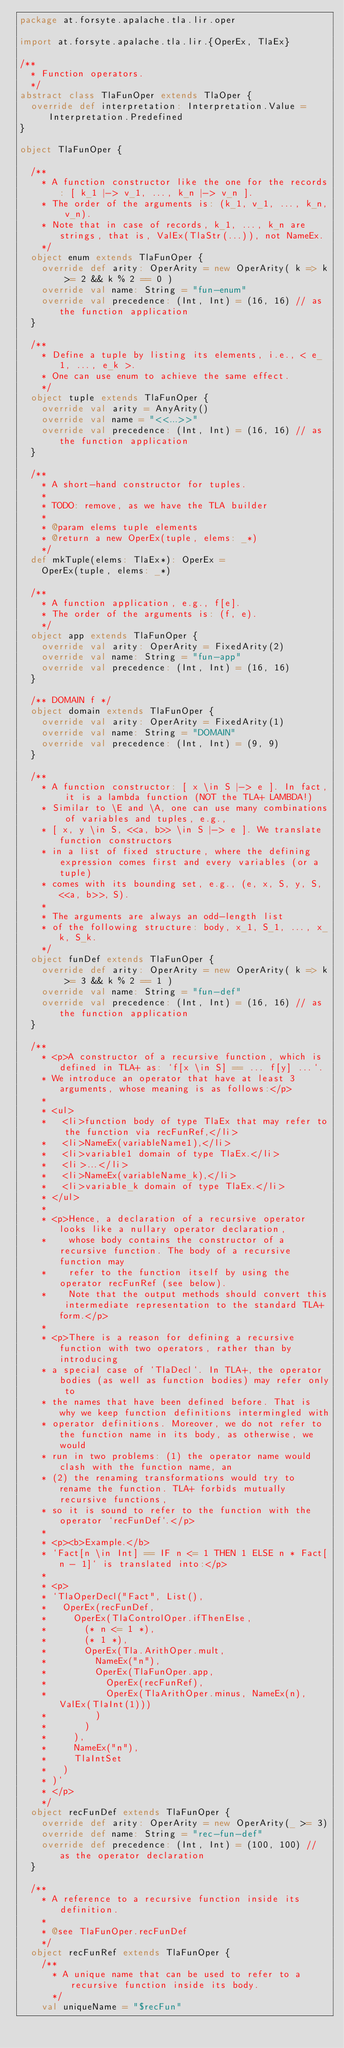Convert code to text. <code><loc_0><loc_0><loc_500><loc_500><_Scala_>package at.forsyte.apalache.tla.lir.oper

import at.forsyte.apalache.tla.lir.{OperEx, TlaEx}

/**
  * Function operators.
  */
abstract class TlaFunOper extends TlaOper {
  override def interpretation: Interpretation.Value = Interpretation.Predefined
}

object TlaFunOper {

  /**
    * A function constructor like the one for the records: [ k_1 |-> v_1, ..., k_n |-> v_n ].
    * The order of the arguments is: (k_1, v_1, ..., k_n, v_n).
    * Note that in case of records, k_1, ..., k_n are strings, that is, ValEx(TlaStr(...)), not NameEx.
    */
  object enum extends TlaFunOper {
    override def arity: OperArity = new OperArity( k => k >= 2 && k % 2 == 0 )
    override val name: String = "fun-enum"
    override val precedence: (Int, Int) = (16, 16) // as the function application
  }

  /**
    * Define a tuple by listing its elements, i.e., < e_1, ..., e_k >.
    * One can use enum to achieve the same effect.
    */
  object tuple extends TlaFunOper {
    override val arity = AnyArity()
    override val name = "<<...>>"
    override val precedence: (Int, Int) = (16, 16) // as the function application
  }

  /**
    * A short-hand constructor for tuples.
    *
    * TODO: remove, as we have the TLA builder
    *
    * @param elems tuple elements
    * @return a new OperEx(tuple, elems: _*)
    */
  def mkTuple(elems: TlaEx*): OperEx =
    OperEx(tuple, elems: _*)

  /**
    * A function application, e.g., f[e].
    * The order of the arguments is: (f, e).
    */
  object app extends TlaFunOper {
    override val arity: OperArity = FixedArity(2)
    override val name: String = "fun-app"
    override val precedence: (Int, Int) = (16, 16)
  }

  /** DOMAIN f */
  object domain extends TlaFunOper {
    override val arity: OperArity = FixedArity(1)
    override val name: String = "DOMAIN"
    override val precedence: (Int, Int) = (9, 9)
  }

  /**
    * A function constructor: [ x \in S |-> e ]. In fact, it is a lambda function (NOT the TLA+ LAMBDA!)
    * Similar to \E and \A, one can use many combinations of variables and tuples, e.g.,
    * [ x, y \in S, <<a, b>> \in S |-> e ]. We translate function constructors
    * in a list of fixed structure, where the defining expression comes first and every variables (or a tuple)
    * comes with its bounding set, e.g., (e, x, S, y, S, <<a, b>>, S).
    *
    * The arguments are always an odd-length list
    * of the following structure: body, x_1, S_1, ..., x_k, S_k.
    */
  object funDef extends TlaFunOper {
    override def arity: OperArity = new OperArity( k => k >= 3 && k % 2 == 1 )
    override val name: String = "fun-def"
    override val precedence: (Int, Int) = (16, 16) // as the function application
  }

  /**
    * <p>A constructor of a recursive function, which is defined in TLA+ as: `f[x \in S] == ... f[y] ...`.
    * We introduce an operator that have at least 3 arguments, whose meaning is as follows:</p>
    *
    * <ul>
    *   <li>function body of type TlaEx that may refer to the function via recFunRef,</li>
    *   <li>NameEx(variableName1),</li>
    *   <li>variable1 domain of type TlaEx.</li>
    *   <li>...</li>
    *   <li>NameEx(variableName_k),</li>
    *   <li>variable_k domain of type TlaEx.</li>
    * </ul>
    *
    * <p>Hence, a declaration of a recursive operator looks like a nullary operator declaration,
    *    whose body contains the constructor of a recursive function. The body of a recursive function may
    *    refer to the function itself by using the operator recFunRef (see below).
    *    Note that the output methods should convert this intermediate representation to the standard TLA+ form.</p>
    *
    * <p>There is a reason for defining a recursive function with two operators, rather than by introducing
    * a special case of `TlaDecl`. In TLA+, the operator bodies (as well as function bodies) may refer only to
    * the names that have been defined before. That is why we keep function definitions intermingled with
    * operator definitions. Moreover, we do not refer to the function name in its body, as otherwise, we would
    * run in two problems: (1) the operator name would clash with the function name, an
    * (2) the renaming transformations would try to rename the function. TLA+ forbids mutually recursive functions,
    * so it is sound to refer to the function with the operator `recFunDef`.</p>
    *
    * <p><b>Example.</b>
    * `Fact[n \in Int] == IF n <= 1 THEN 1 ELSE n * Fact[n - 1]` is translated into:</p>
    *
    * <p>
    * `TlaOperDecl("Fact", List(),
    *   OperEx(recFunDef,
    *     OperEx(TlaControlOper.ifThenElse,
    *       (* n <= 1 *),
    *       (* 1 *),
    *       OperEx(Tla.ArithOper.mult,
    *         NameEx("n"),
    *         OperEx(TlaFunOper.app,
    *           OperEx(recFunRef),
    *           OperEx(TlaArithOper.minus, NameEx(n), ValEx(TlaInt(1)))
    *         )
    *       )
    *     ),
    *     NameEx("n"),
    *     TlaIntSet
    *   )
    * )`
    * </p>
    */
  object recFunDef extends TlaFunOper {
    override def arity: OperArity = new OperArity(_ >= 3)
    override def name: String = "rec-fun-def"
    override def precedence: (Int, Int) = (100, 100) // as the operator declaration
  }

  /**
    * A reference to a recursive function inside its definition.
    *
    * @see TlaFunOper.recFunDef
    */
  object recFunRef extends TlaFunOper {
    /**
      * A unique name that can be used to refer to a recursive function inside its body.
      */
    val uniqueName = "$recFun"</code> 